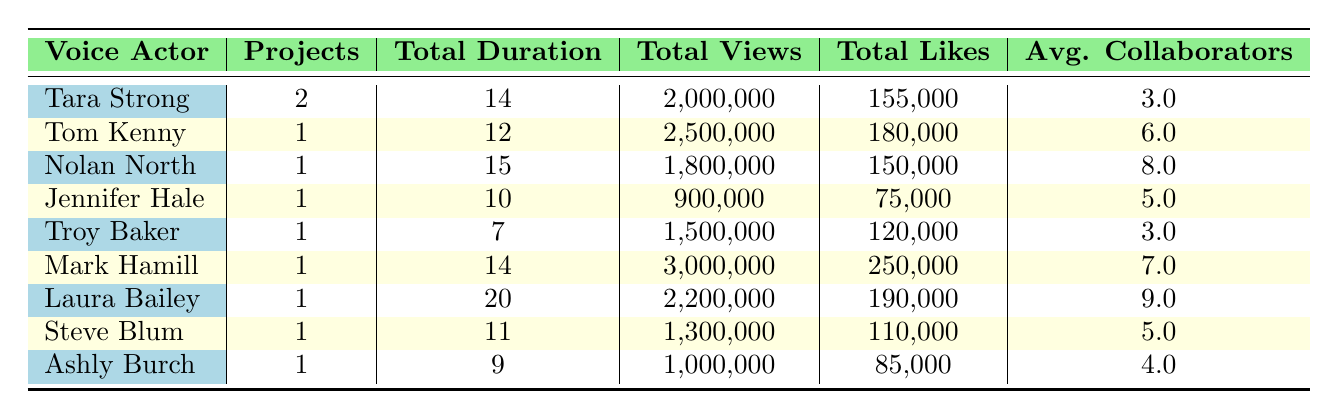What is the total duration of projects for Laura Bailey? The table shows that Laura Bailey has only one project, which has a total duration of 20 minutes.
Answer: 20 Which voice actor has the highest total views? By comparing the total views of each voice actor in the table, Mark Hamill has the highest total views at 3,000,000.
Answer: Mark Hamill What is the average number of collaborators for the projects listed? To find the average, sum the total collaborators (3 + 6 + 8 + 5 + 3 + 7 + 9 + 5 + 4 = 50) and divide by the number of projects (9). Thus, the average is 50/9, which is approximately 5.56.
Answer: 5.56 Did Ashly Burch work on a project that had more than 1 million views? Ashly Burch's project has 1,000,000 views, which meets the condition of being more than 1 million. Therefore, the answer is yes.
Answer: Yes How many projects feature 3D CGI animation style, and what is their total duration? There are two projects with 3D CGI animation style: one by Tom Kenny (12 minutes) and another by Laura Bailey (20 minutes). Adding these durations gives 12 + 20 = 32 minutes.
Answer: 2 projects, 32 minutes Which animation style has the lowest average number of collaborators? The average collaborators by animation style must be calculated. 2D Traditional has an average of 5.5; 3D CGI has 7.5; Motion Capture has 6; Rotoscoping has 5; Stop Motion has 3; Flash Animation has 2; Anime-style has 5. Thus, Flash Animation has the lowest average with 2.
Answer: Flash Animation What percentage of total likes does Tara Strong's projects account for out of the total likes in the table? Summing the likes in the table gives a total of 1,110,000. Tara Strong has 155,000 likes, so the percentage is (155,000 / 1,110,000) * 100, which is approximately 13.93%.
Answer: 13.93% Is there any collaboration that includes more than 9 collaborators? Upon reviewing the table, Laura Bailey's project features 9 collaborators, but none exceed that number. Thus, the answer is no.
Answer: No Which voice actor has a project with their total likes exceeding 250,000? By examining the likes in the table, Mark Hamill has the highest number (250,000), which qualifies. So, he exceeds this amount compared to others.
Answer: Mark Hamill 